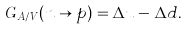<formula> <loc_0><loc_0><loc_500><loc_500>G _ { A / V } ( n \rightarrow p ) = \Delta u - \Delta d .</formula> 